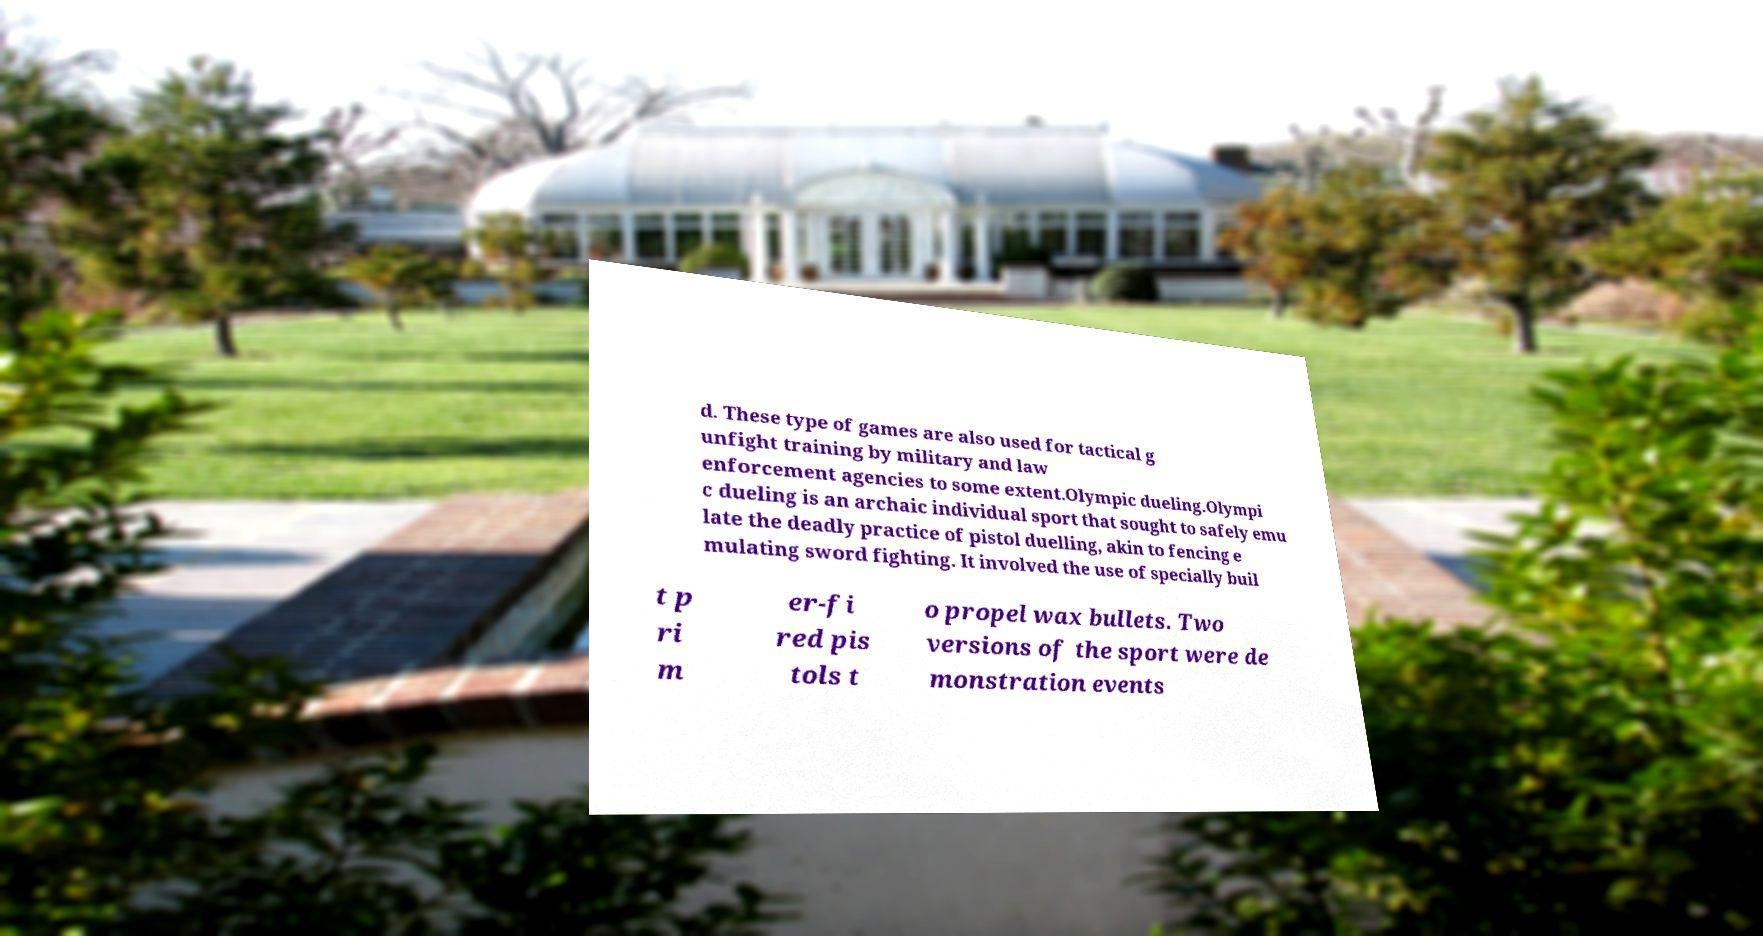For documentation purposes, I need the text within this image transcribed. Could you provide that? d. These type of games are also used for tactical g unfight training by military and law enforcement agencies to some extent.Olympic dueling.Olympi c dueling is an archaic individual sport that sought to safely emu late the deadly practice of pistol duelling, akin to fencing e mulating sword fighting. It involved the use of specially buil t p ri m er-fi red pis tols t o propel wax bullets. Two versions of the sport were de monstration events 